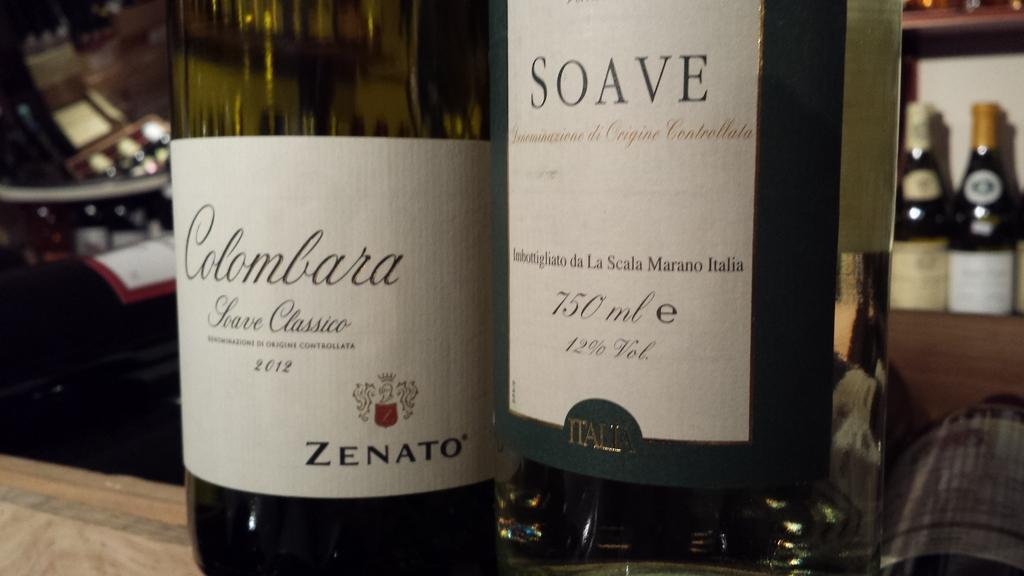<image>
Create a compact narrative representing the image presented. Two different brands of Soave wine sit on a counter. 